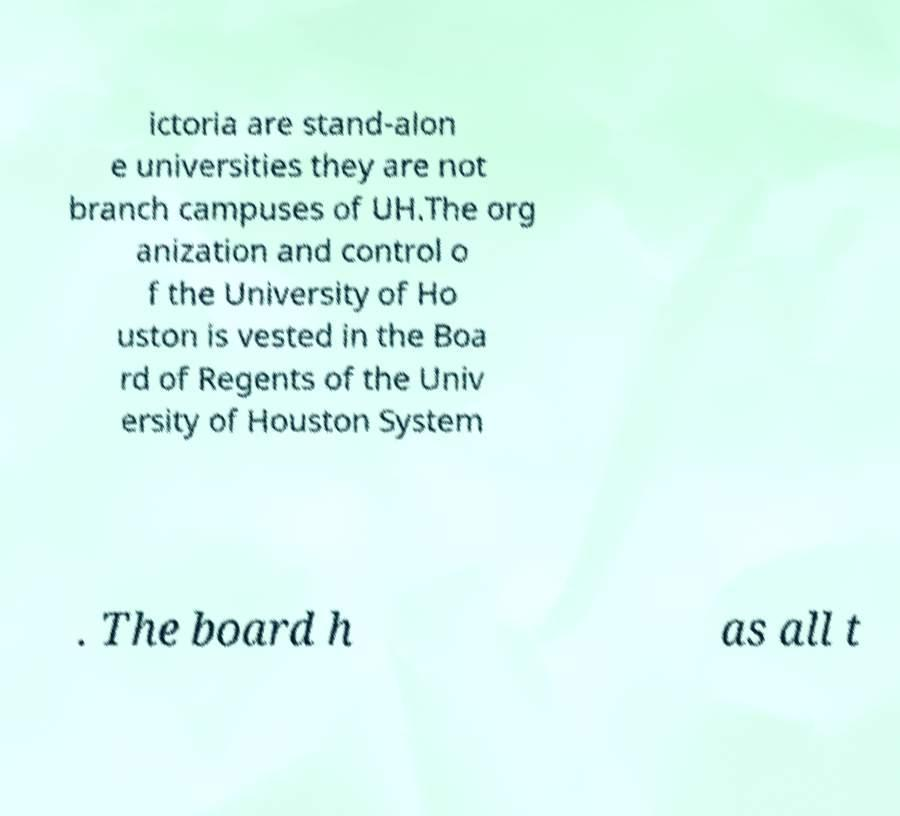I need the written content from this picture converted into text. Can you do that? ictoria are stand-alon e universities they are not branch campuses of UH.The org anization and control o f the University of Ho uston is vested in the Boa rd of Regents of the Univ ersity of Houston System . The board h as all t 